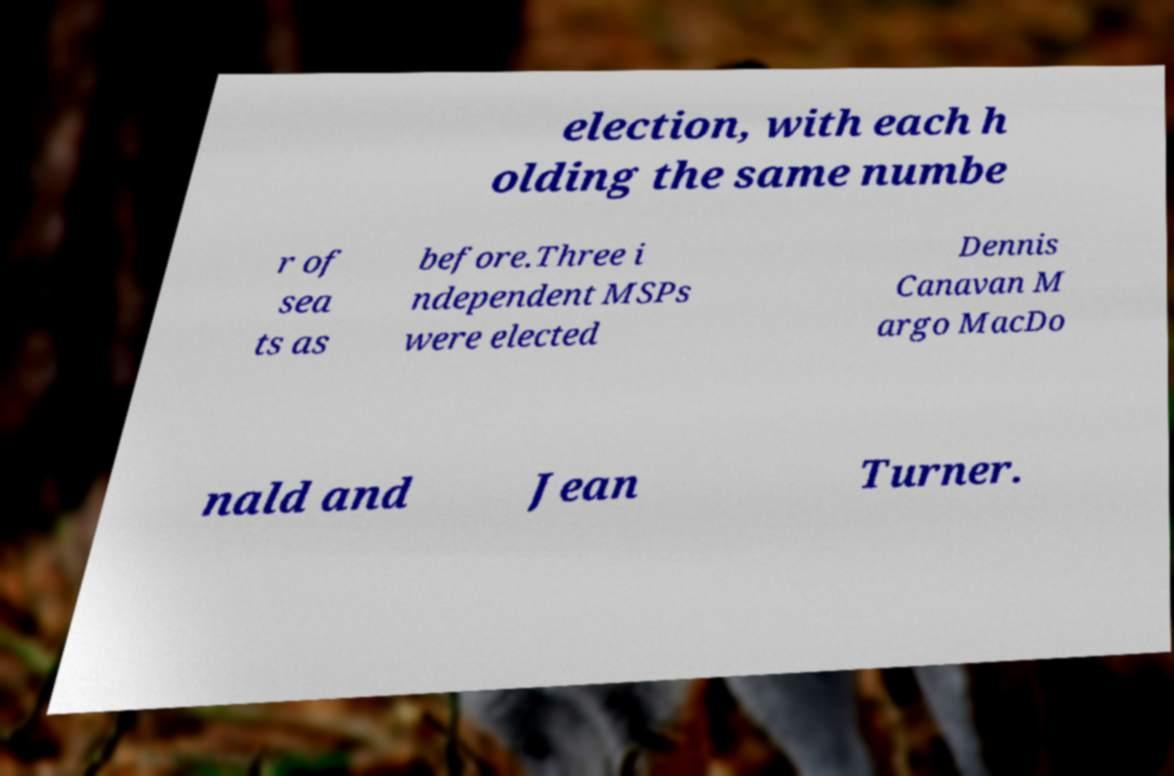Please read and relay the text visible in this image. What does it say? election, with each h olding the same numbe r of sea ts as before.Three i ndependent MSPs were elected Dennis Canavan M argo MacDo nald and Jean Turner. 